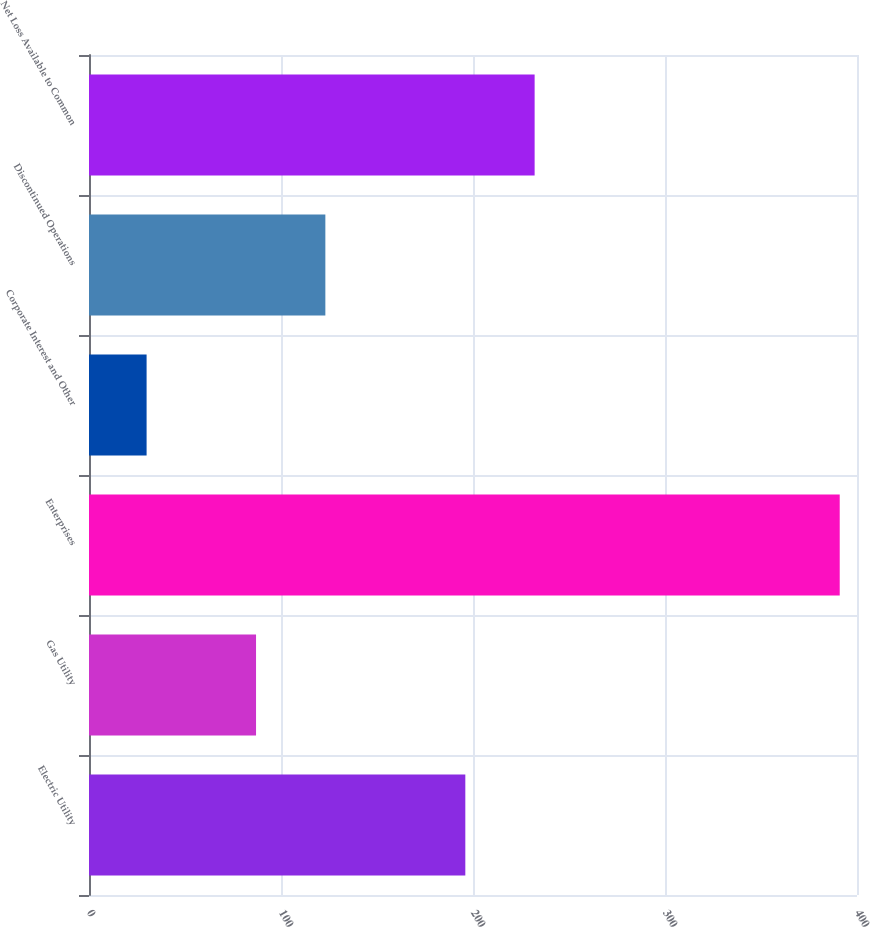<chart> <loc_0><loc_0><loc_500><loc_500><bar_chart><fcel>Electric Utility<fcel>Gas Utility<fcel>Enterprises<fcel>Corporate Interest and Other<fcel>Discontinued Operations<fcel>Net Loss Available to Common<nl><fcel>196<fcel>87<fcel>391<fcel>30<fcel>123.1<fcel>232.1<nl></chart> 